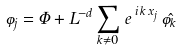Convert formula to latex. <formula><loc_0><loc_0><loc_500><loc_500>\varphi _ { j } = \Phi + L ^ { - d } \sum _ { { k } \neq { 0 } } \, e \, ^ { i \, { k \, x } _ { j } } \, \hat { \varphi } _ { k }</formula> 